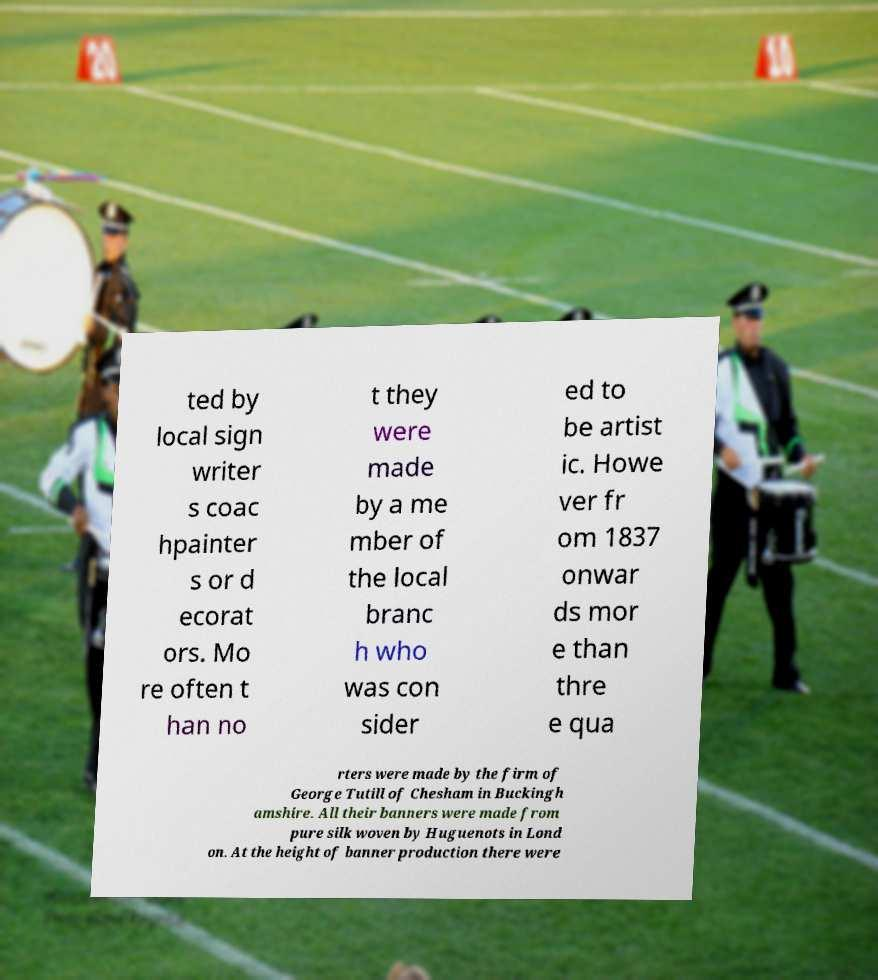Please identify and transcribe the text found in this image. ted by local sign writer s coac hpainter s or d ecorat ors. Mo re often t han no t they were made by a me mber of the local branc h who was con sider ed to be artist ic. Howe ver fr om 1837 onwar ds mor e than thre e qua rters were made by the firm of George Tutill of Chesham in Buckingh amshire. All their banners were made from pure silk woven by Huguenots in Lond on. At the height of banner production there were 